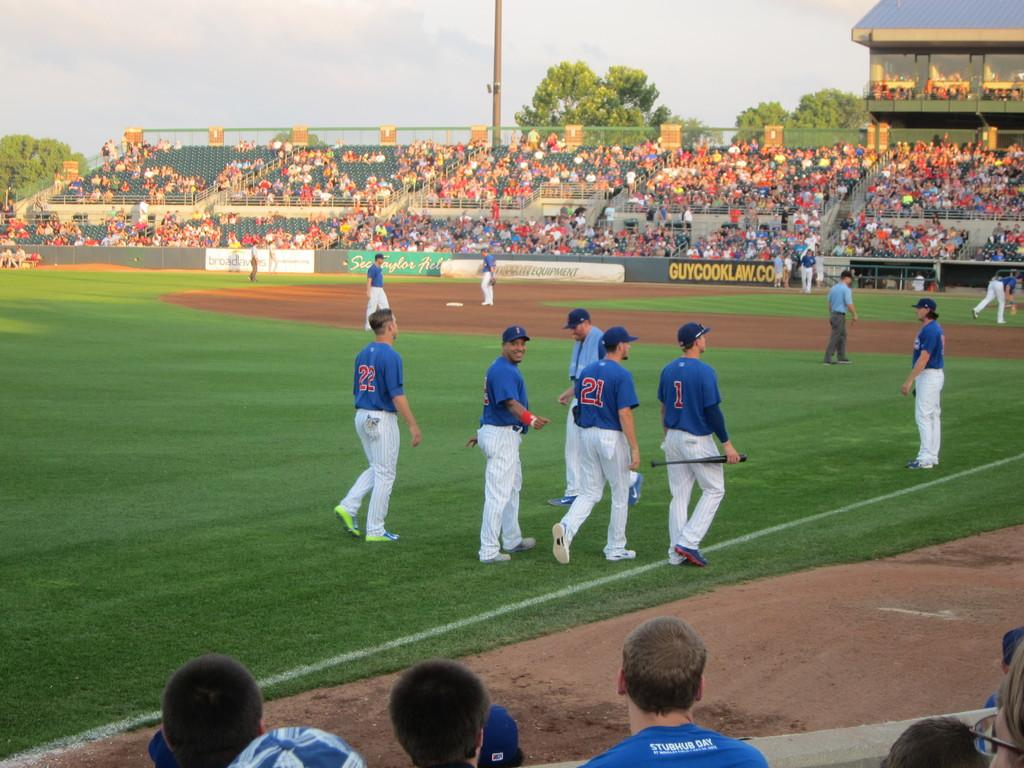<image>
Write a terse but informative summary of the picture. a banner on the fence at a baseball field for guycooklaw.com 